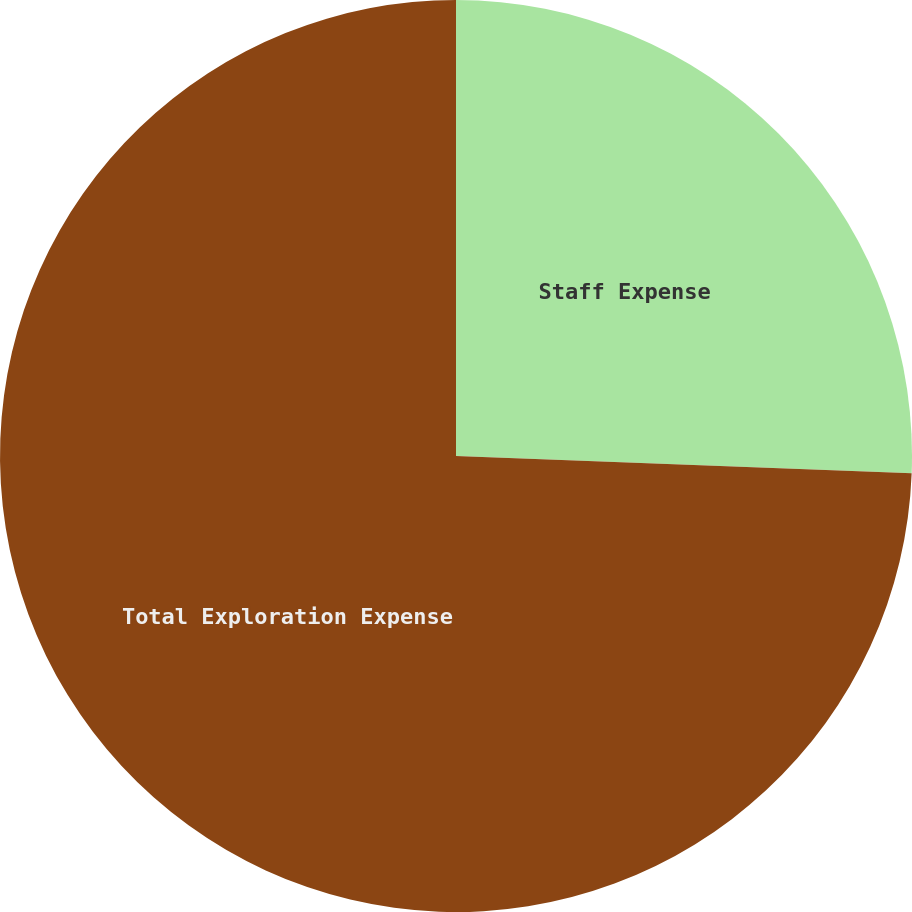Convert chart. <chart><loc_0><loc_0><loc_500><loc_500><pie_chart><fcel>Staff Expense<fcel>Total Exploration Expense<nl><fcel>25.6%<fcel>74.4%<nl></chart> 